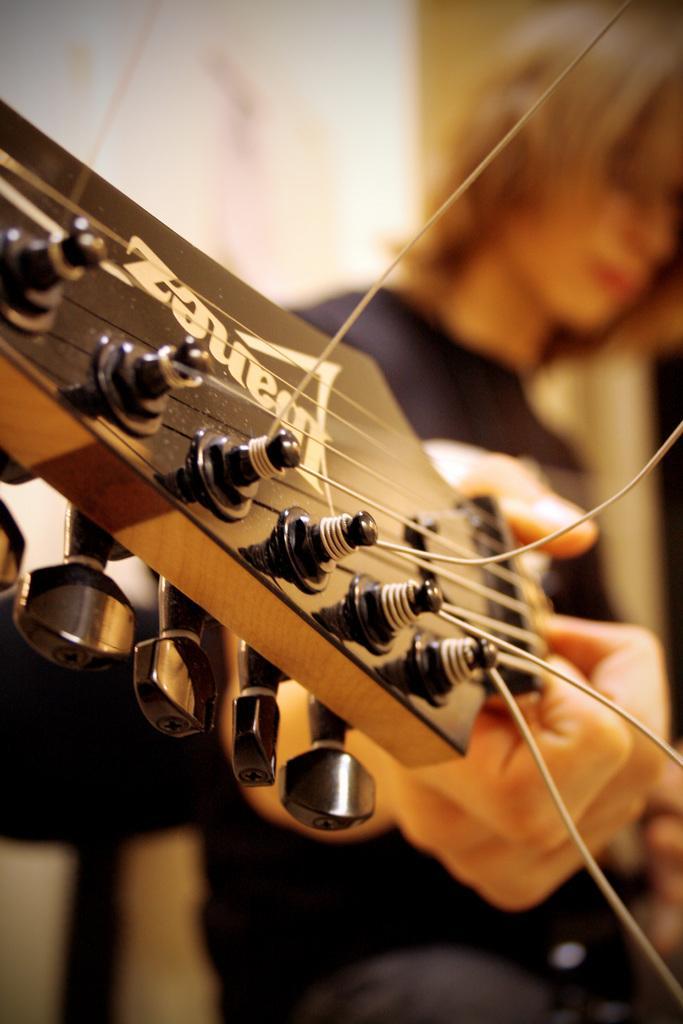Can you describe this image briefly? In this picture we can see a man wore black color T-Shirt and here in front we can see guitar strings some persons hand is playing it. 